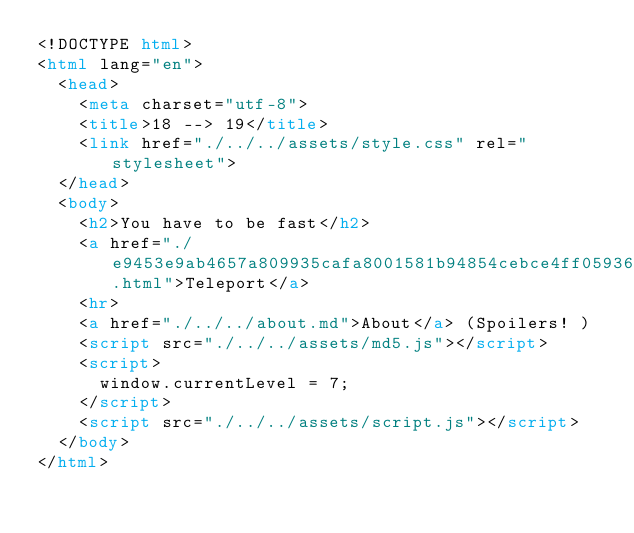<code> <loc_0><loc_0><loc_500><loc_500><_HTML_><!DOCTYPE html>
<html lang="en">
  <head>
    <meta charset="utf-8">
    <title>18 --> 19</title>
    <link href="./../../assets/style.css" rel="stylesheet">
  </head>
  <body>
    <h2>You have to be fast</h2>
    <a href="./e9453e9ab4657a809935cafa8001581b94854cebce4ff059366eb917244fc397.html">Teleport</a>
    <hr>
    <a href="./../../about.md">About</a> (Spoilers! )
    <script src="./../../assets/md5.js"></script>
    <script>
      window.currentLevel = 7;
    </script>
    <script src="./../../assets/script.js"></script>
  </body>
</html></code> 